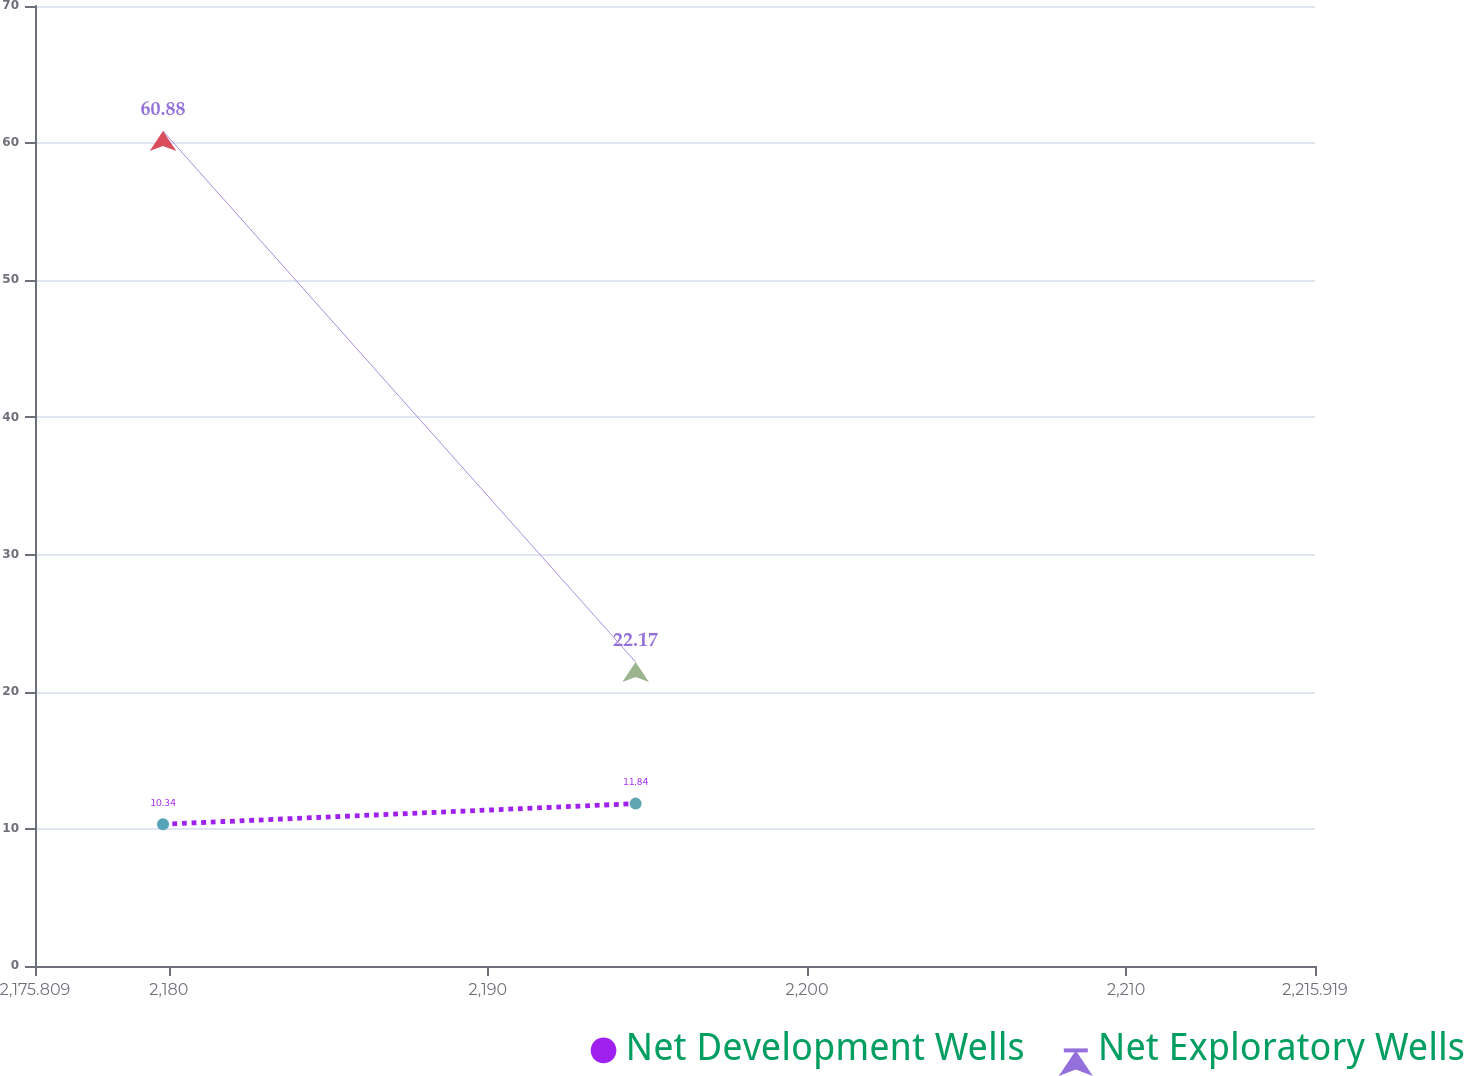Convert chart to OTSL. <chart><loc_0><loc_0><loc_500><loc_500><line_chart><ecel><fcel>Net Development Wells<fcel>Net Exploratory Wells<nl><fcel>2179.82<fcel>10.34<fcel>60.88<nl><fcel>2194.63<fcel>11.84<fcel>22.17<nl><fcel>2219.93<fcel>9.34<fcel>40.35<nl></chart> 